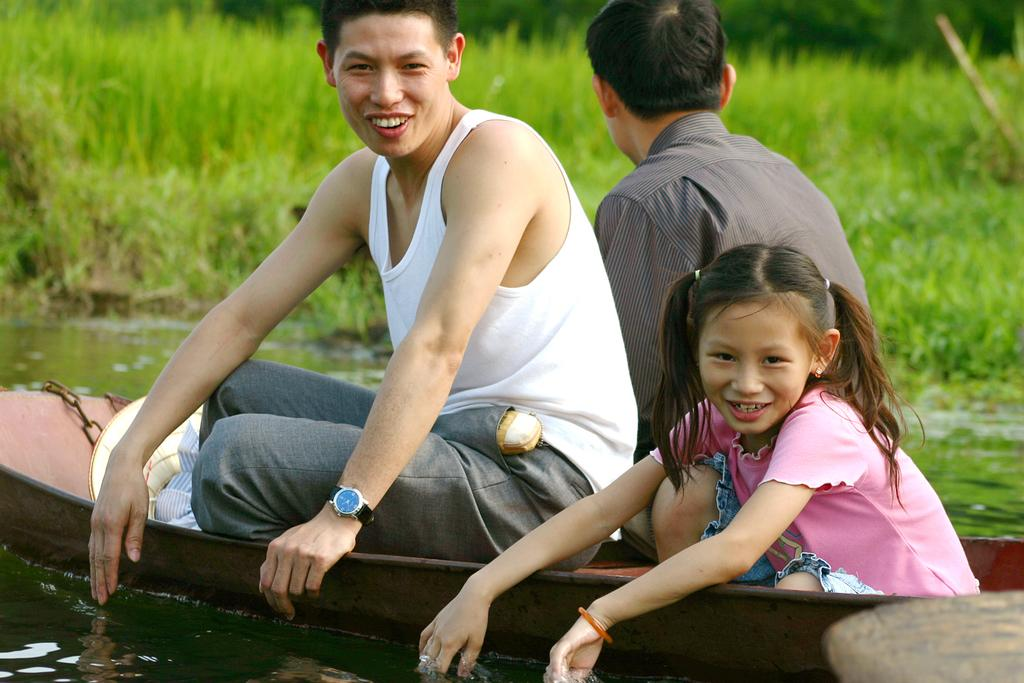How many people are in the image? There are three persons in the image. What are the persons doing in the image? The persons are sitting on a boat. Where is the boat located in the image? The boat is on water. What type of vegetation can be seen in the image? There is grass visible in the image. Can you identify any accessories worn by one of the persons? One person is wearing a watch. What type of quilt is being used to cover the boat in the image? There is no quilt present in the image; the boat is on water with the persons sitting on it. What emotion can be seen on the faces of the persons in the image? The provided facts do not mention any emotions or facial expressions of the persons in the image. 